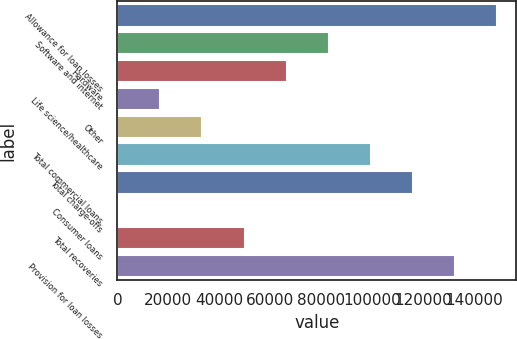Convert chart. <chart><loc_0><loc_0><loc_500><loc_500><bar_chart><fcel>Allowance for loan losses<fcel>Software and internet<fcel>Hardware<fcel>Life science/healthcare<fcel>Other<fcel>Total commercial loans<fcel>Total charge-offs<fcel>Consumer loans<fcel>Total recoveries<fcel>Provision for loan losses<nl><fcel>148861<fcel>82869<fcel>66371<fcel>16877<fcel>33375<fcel>99367<fcel>115865<fcel>379<fcel>49873<fcel>132363<nl></chart> 